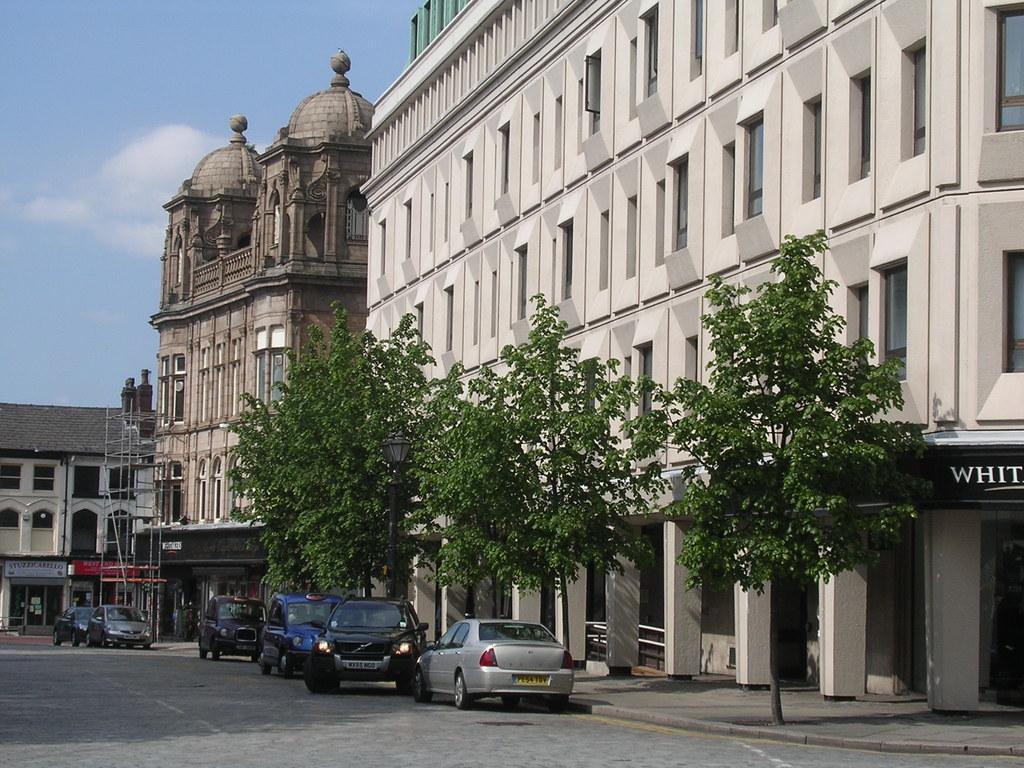Can you describe this image briefly? In this image I can see the road, few vehicles on the road, few trees which are green in color and few buildings. In the background I can see the sky. 